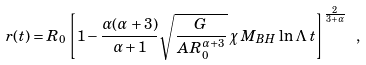<formula> <loc_0><loc_0><loc_500><loc_500>r ( t ) = R _ { 0 } \left [ 1 - \frac { \alpha ( \alpha + 3 ) } { \alpha + 1 } \sqrt { \frac { G } { A R _ { 0 } ^ { \alpha + 3 } } } \, \chi \, M _ { B H } \, \ln \Lambda \, t \right ] ^ { \frac { 2 } { 3 + \alpha } } \ ,</formula> 